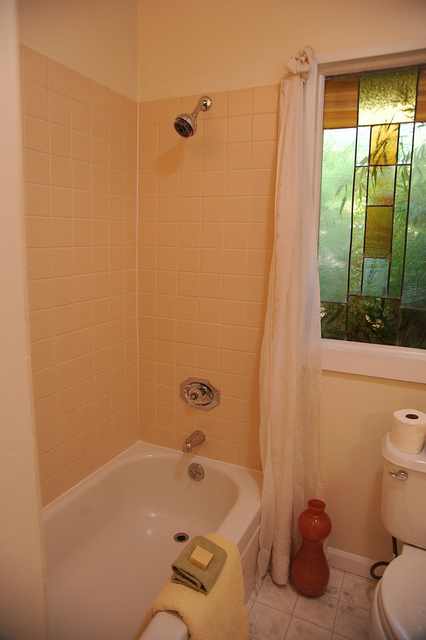<image>Is the window painted? I don't know if the window is painted. It can be both painted and not painted. Is the window painted? I don't know if the window is painted. It can be both painted and not painted. 